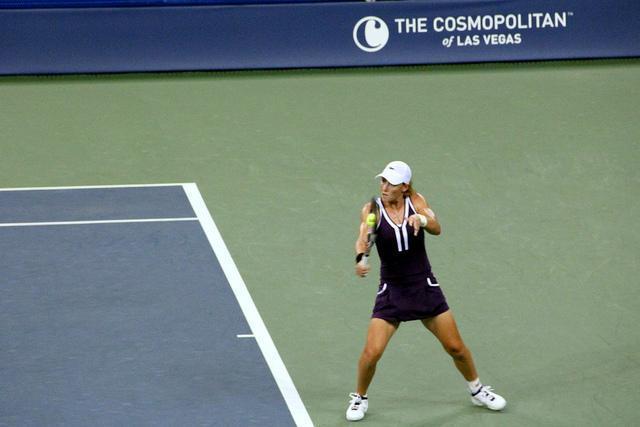How many people by the wall?
Give a very brief answer. 0. 